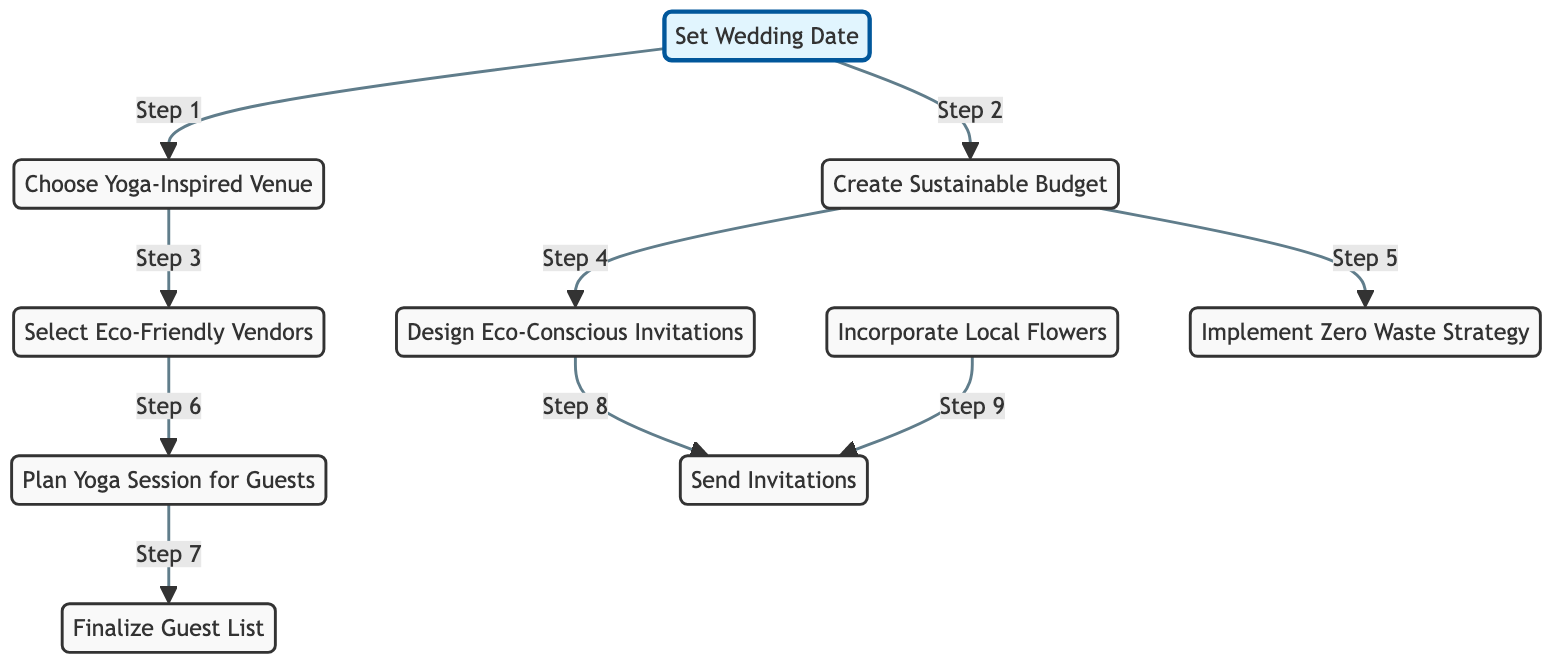What is the first step in the wedding planning timeline? The first step is represented by the node labeled "Set Wedding Date", which is where the planning begins.
Answer: Set Wedding Date How many nodes are there in the directed graph? By counting all the individual items listed as nodes, we find there are ten distinct nodes represented in the graph.
Answer: Ten What is the relationship between "Choose Yoga-Inspired Venue" and "Select Eco-Friendly Vendors"? The "Choose Yoga-Inspired Venue" node points to the "Select Eco-Friendly Vendors" node, indicating that selecting a venue follows choosing a yoga-inspired venue.
Answer: Choose Yoga-Inspired Venue → Select Eco-Friendly Vendors Which step directly follows "Plan Yoga Session for Guests"? The directed edge leads from "Plan Yoga Session for Guests" to "Finalize Guest List", indicating that finalizing the guest list is the next step after planning the yoga session.
Answer: Finalize Guest List What are two elements of the sustainable budget process? From the diagram, the sustainable budget process is connected to designing eco-conscious invitations and implementing a zero waste strategy, both of which depend on creating a sustainable budget.
Answer: Design Eco-Conscious Invitations, Implement Zero Waste Strategy How many edges are present in this diagram? Counting each directed edge that connects the nodes gives us a total of eight edges in the diagram.
Answer: Eight What happens after designing eco-conscious invitations? After the "Design Eco-Conscious Invitations" step, the directed edge leads to the "Send Invitations" step, indicating that sending out invitations follows designing them.
Answer: Send Invitations Which node does not have any outgoing edges? The node "Incorporate Local Flowers" does not point to any other node, indicating it is not followed by any subsequent action.
Answer: Incorporate Local Flowers What is the last major milestone in the timeline? The last significant milestone is represented by the node labeled "Send Invitations", indicating it is the final major task in the timeline.
Answer: Send Invitations 